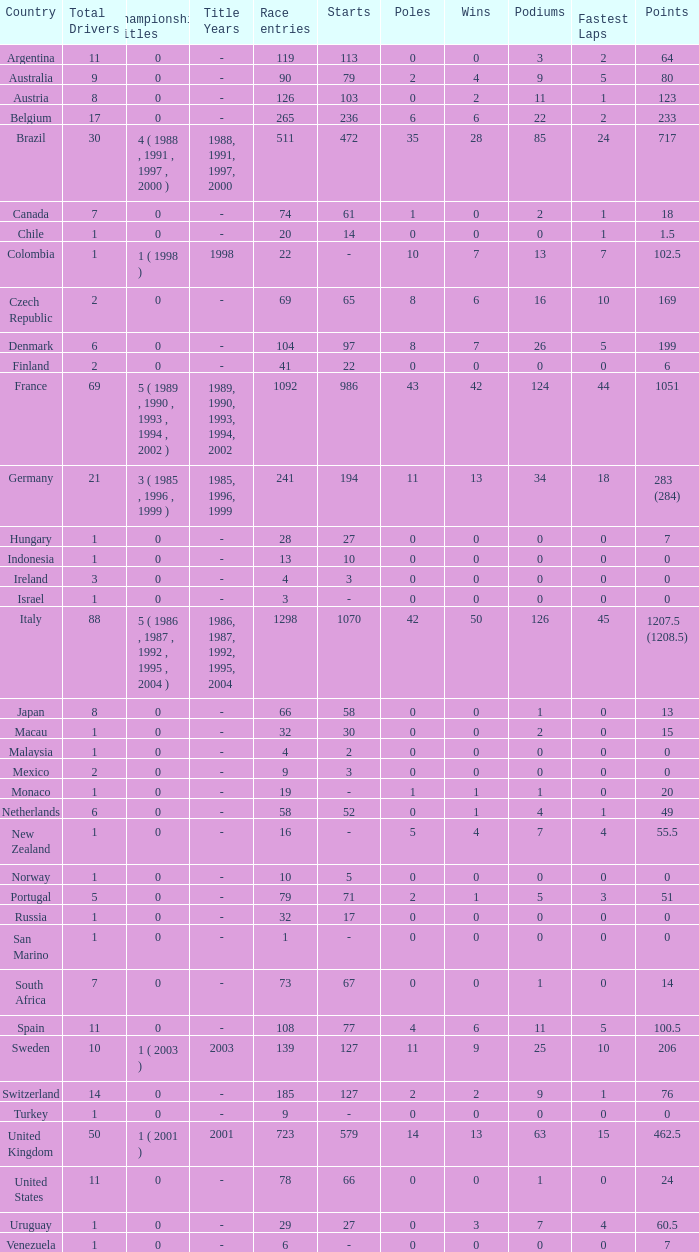Give me the full table as a dictionary. {'header': ['Country', 'Total Drivers', 'Championship Titles', 'Title Years', 'Race entries', 'Starts', 'Poles', 'Wins', 'Podiums', 'Fastest Laps', 'Points'], 'rows': [['Argentina', '11', '0', '-', '119', '113', '0', '0', '3', '2', '64'], ['Australia', '9', '0', '-', '90', '79', '2', '4', '9', '5', '80'], ['Austria', '8', '0', '-', '126', '103', '0', '2', '11', '1', '123'], ['Belgium', '17', '0', '-', '265', '236', '6', '6', '22', '2', '233'], ['Brazil', '30', '4 ( 1988 , 1991 , 1997 , 2000 )', '1988, 1991, 1997, 2000', '511', '472', '35', '28', '85', '24', '717'], ['Canada', '7', '0', '-', '74', '61', '1', '0', '2', '1', '18'], ['Chile', '1', '0', '-', '20', '14', '0', '0', '0', '1', '1.5'], ['Colombia', '1', '1 ( 1998 )', '1998', '22', '-', '10', '7', '13', '7', '102.5'], ['Czech Republic', '2', '0', '-', '69', '65', '8', '6', '16', '10', '169'], ['Denmark', '6', '0', '-', '104', '97', '8', '7', '26', '5', '199'], ['Finland', '2', '0', '-', '41', '22', '0', '0', '0', '0', '6'], ['France', '69', '5 ( 1989 , 1990 , 1993 , 1994 , 2002 )', '1989, 1990, 1993, 1994, 2002', '1092', '986', '43', '42', '124', '44', '1051'], ['Germany', '21', '3 ( 1985 , 1996 , 1999 )', '1985, 1996, 1999', '241', '194', '11', '13', '34', '18', '283 (284)'], ['Hungary', '1', '0', '-', '28', '27', '0', '0', '0', '0', '7'], ['Indonesia', '1', '0', '-', '13', '10', '0', '0', '0', '0', '0'], ['Ireland', '3', '0', '-', '4', '3', '0', '0', '0', '0', '0'], ['Israel', '1', '0', '-', '3', '-', '0', '0', '0', '0', '0'], ['Italy', '88', '5 ( 1986 , 1987 , 1992 , 1995 , 2004 )', '1986, 1987, 1992, 1995, 2004', '1298', '1070', '42', '50', '126', '45', '1207.5 (1208.5)'], ['Japan', '8', '0', '-', '66', '58', '0', '0', '1', '0', '13'], ['Macau', '1', '0', '-', '32', '30', '0', '0', '2', '0', '15'], ['Malaysia', '1', '0', '-', '4', '2', '0', '0', '0', '0', '0'], ['Mexico', '2', '0', '-', '9', '3', '0', '0', '0', '0', '0'], ['Monaco', '1', '0', '-', '19', '-', '1', '1', '1', '0', '20'], ['Netherlands', '6', '0', '-', '58', '52', '0', '1', '4', '1', '49'], ['New Zealand', '1', '0', '-', '16', '-', '5', '4', '7', '4', '55.5'], ['Norway', '1', '0', '-', '10', '5', '0', '0', '0', '0', '0'], ['Portugal', '5', '0', '-', '79', '71', '2', '1', '5', '3', '51'], ['Russia', '1', '0', '-', '32', '17', '0', '0', '0', '0', '0'], ['San Marino', '1', '0', '-', '1', '-', '0', '0', '0', '0', '0'], ['South Africa', '7', '0', '-', '73', '67', '0', '0', '1', '0', '14'], ['Spain', '11', '0', '-', '108', '77', '4', '6', '11', '5', '100.5'], ['Sweden', '10', '1 ( 2003 )', '2003', '139', '127', '11', '9', '25', '10', '206'], ['Switzerland', '14', '0', '-', '185', '127', '2', '2', '9', '1', '76'], ['Turkey', '1', '0', '-', '9', '-', '0', '0', '0', '0', '0'], ['United Kingdom', '50', '1 ( 2001 )', '2001', '723', '579', '14', '13', '63', '15', '462.5'], ['United States', '11', '0', '-', '78', '66', '0', '0', '1', '0', '24'], ['Uruguay', '1', '0', '-', '29', '27', '0', '3', '7', '4', '60.5'], ['Venezuela', '1', '0', '-', '6', '-', '0', '0', '0', '0', '7']]} How many fastest laps for the nation with 32 (30) entries and starts and fewer than 2 podiums? None. 